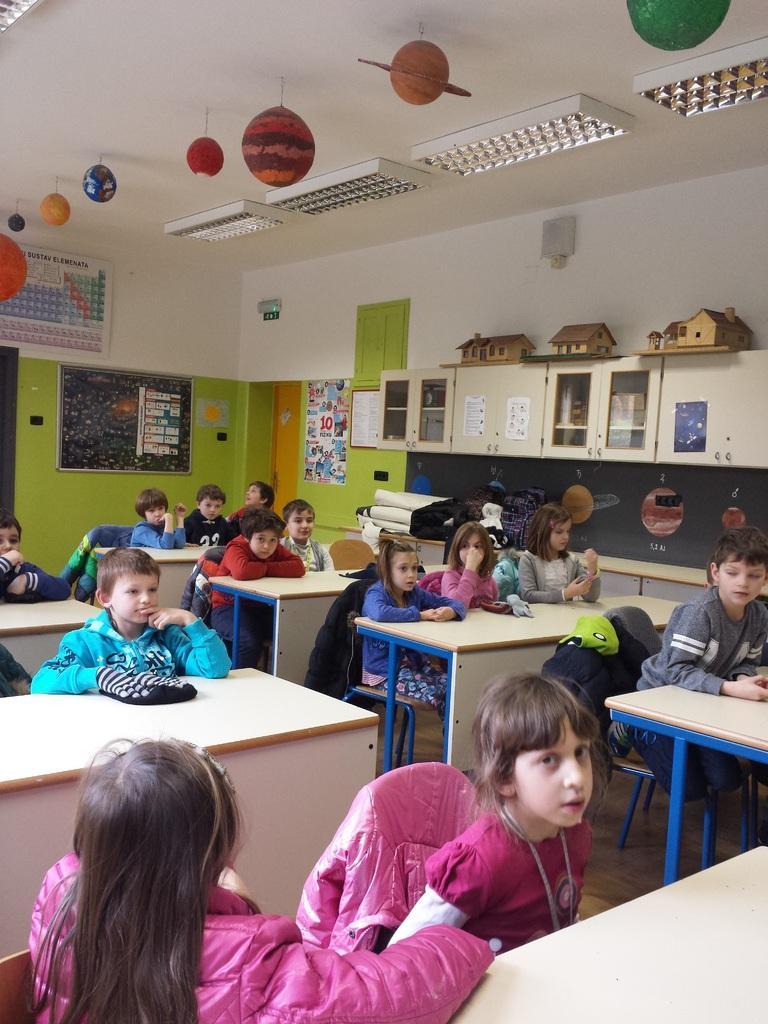What type of setting is shown in the image? The image depicts a classroom. What are the kids doing in the classroom? Kids are sitting on chairs at tables in the classroom. What can be seen in the background of the image? There are cupboards in the background. What is present on the walls of the classroom? Posters are present on the walls. What is visible on the roof top of the classroom? Lights are visible on the roof top. How many boats are present in the classroom? There are no boats present in the classroom; it is a learning environment with desks, chairs, and educational materials. 